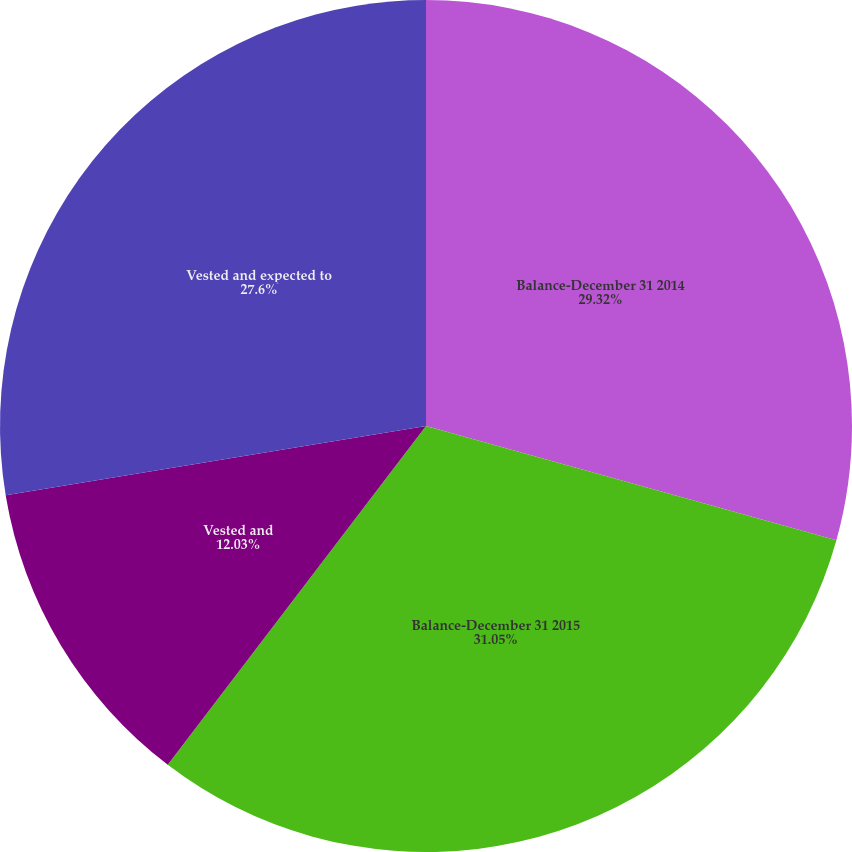Convert chart to OTSL. <chart><loc_0><loc_0><loc_500><loc_500><pie_chart><fcel>Balance-December 31 2014<fcel>Balance-December 31 2015<fcel>Vested and<fcel>Vested and expected to<nl><fcel>29.32%<fcel>31.04%<fcel>12.03%<fcel>27.6%<nl></chart> 